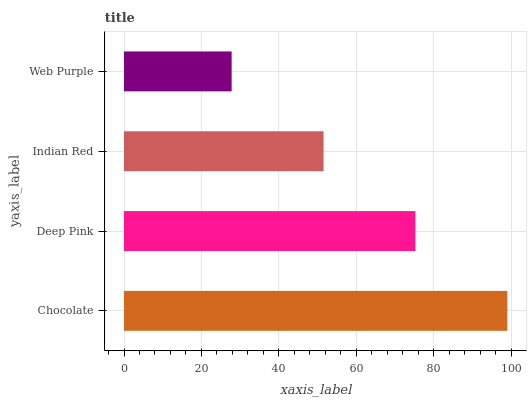Is Web Purple the minimum?
Answer yes or no. Yes. Is Chocolate the maximum?
Answer yes or no. Yes. Is Deep Pink the minimum?
Answer yes or no. No. Is Deep Pink the maximum?
Answer yes or no. No. Is Chocolate greater than Deep Pink?
Answer yes or no. Yes. Is Deep Pink less than Chocolate?
Answer yes or no. Yes. Is Deep Pink greater than Chocolate?
Answer yes or no. No. Is Chocolate less than Deep Pink?
Answer yes or no. No. Is Deep Pink the high median?
Answer yes or no. Yes. Is Indian Red the low median?
Answer yes or no. Yes. Is Web Purple the high median?
Answer yes or no. No. Is Deep Pink the low median?
Answer yes or no. No. 